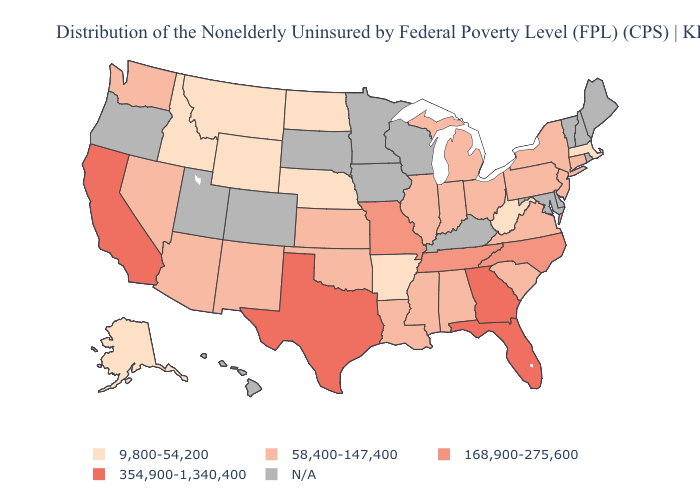Which states have the lowest value in the Northeast?
Quick response, please. Massachusetts. How many symbols are there in the legend?
Be succinct. 5. What is the highest value in states that border Oregon?
Quick response, please. 354,900-1,340,400. What is the value of Alabama?
Keep it brief. 58,400-147,400. Does the first symbol in the legend represent the smallest category?
Keep it brief. Yes. Which states have the lowest value in the USA?
Quick response, please. Alaska, Arkansas, Idaho, Massachusetts, Montana, Nebraska, North Dakota, West Virginia, Wyoming. Name the states that have a value in the range 168,900-275,600?
Answer briefly. Missouri, North Carolina, Tennessee. What is the lowest value in the USA?
Short answer required. 9,800-54,200. Name the states that have a value in the range 9,800-54,200?
Write a very short answer. Alaska, Arkansas, Idaho, Massachusetts, Montana, Nebraska, North Dakota, West Virginia, Wyoming. Does Illinois have the lowest value in the MidWest?
Short answer required. No. What is the value of Illinois?
Short answer required. 58,400-147,400. Which states hav the highest value in the MidWest?
Concise answer only. Missouri. What is the value of Florida?
Keep it brief. 354,900-1,340,400. Name the states that have a value in the range 58,400-147,400?
Give a very brief answer. Alabama, Arizona, Connecticut, Illinois, Indiana, Kansas, Louisiana, Michigan, Mississippi, Nevada, New Jersey, New Mexico, New York, Ohio, Oklahoma, Pennsylvania, South Carolina, Virginia, Washington. 